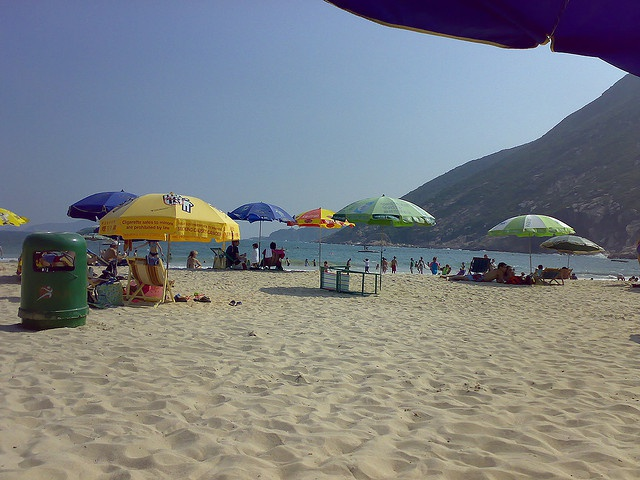Describe the objects in this image and their specific colors. I can see umbrella in gray, olive, and khaki tones, umbrella in gray, darkgray, and purple tones, people in gray and black tones, chair in gray, olive, maroon, and black tones, and umbrella in gray, darkgray, darkgreen, and black tones in this image. 